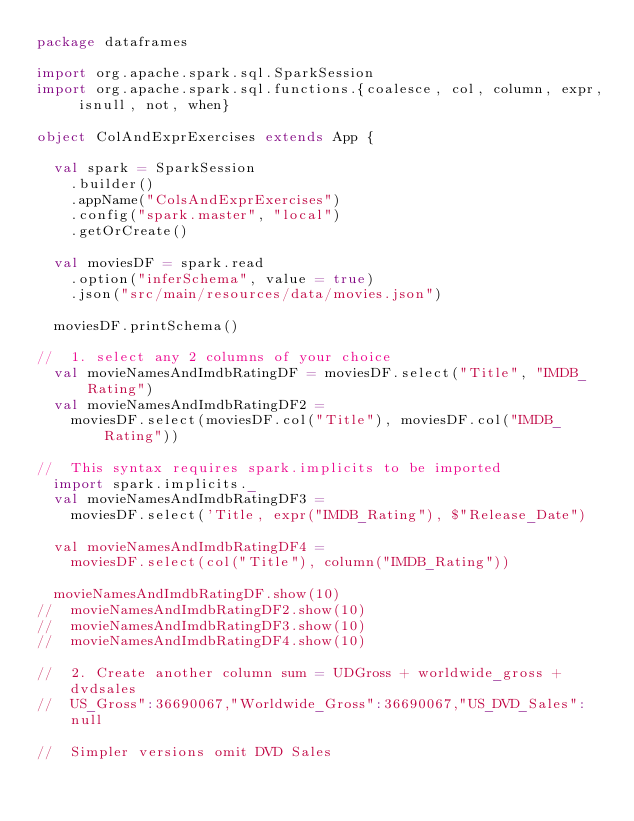<code> <loc_0><loc_0><loc_500><loc_500><_Scala_>package dataframes

import org.apache.spark.sql.SparkSession
import org.apache.spark.sql.functions.{coalesce, col, column, expr, isnull, not, when}

object ColAndExprExercises extends App {

  val spark = SparkSession
    .builder()
    .appName("ColsAndExprExercises")
    .config("spark.master", "local")
    .getOrCreate()

  val moviesDF = spark.read
    .option("inferSchema", value = true)
    .json("src/main/resources/data/movies.json")

  moviesDF.printSchema()

//  1. select any 2 columns of your choice
  val movieNamesAndImdbRatingDF = moviesDF.select("Title", "IMDB_Rating")
  val movieNamesAndImdbRatingDF2 =
    moviesDF.select(moviesDF.col("Title"), moviesDF.col("IMDB_Rating"))

//  This syntax requires spark.implicits to be imported
  import spark.implicits._
  val movieNamesAndImdbRatingDF3 =
    moviesDF.select('Title, expr("IMDB_Rating"), $"Release_Date")

  val movieNamesAndImdbRatingDF4 =
    moviesDF.select(col("Title"), column("IMDB_Rating"))

  movieNamesAndImdbRatingDF.show(10)
//  movieNamesAndImdbRatingDF2.show(10)
//  movieNamesAndImdbRatingDF3.show(10)
//  movieNamesAndImdbRatingDF4.show(10)

//  2. Create another column sum = UDGross + worldwide_gross + dvdsales
//  US_Gross":36690067,"Worldwide_Gross":36690067,"US_DVD_Sales":null

//  Simpler versions omit DVD Sales</code> 